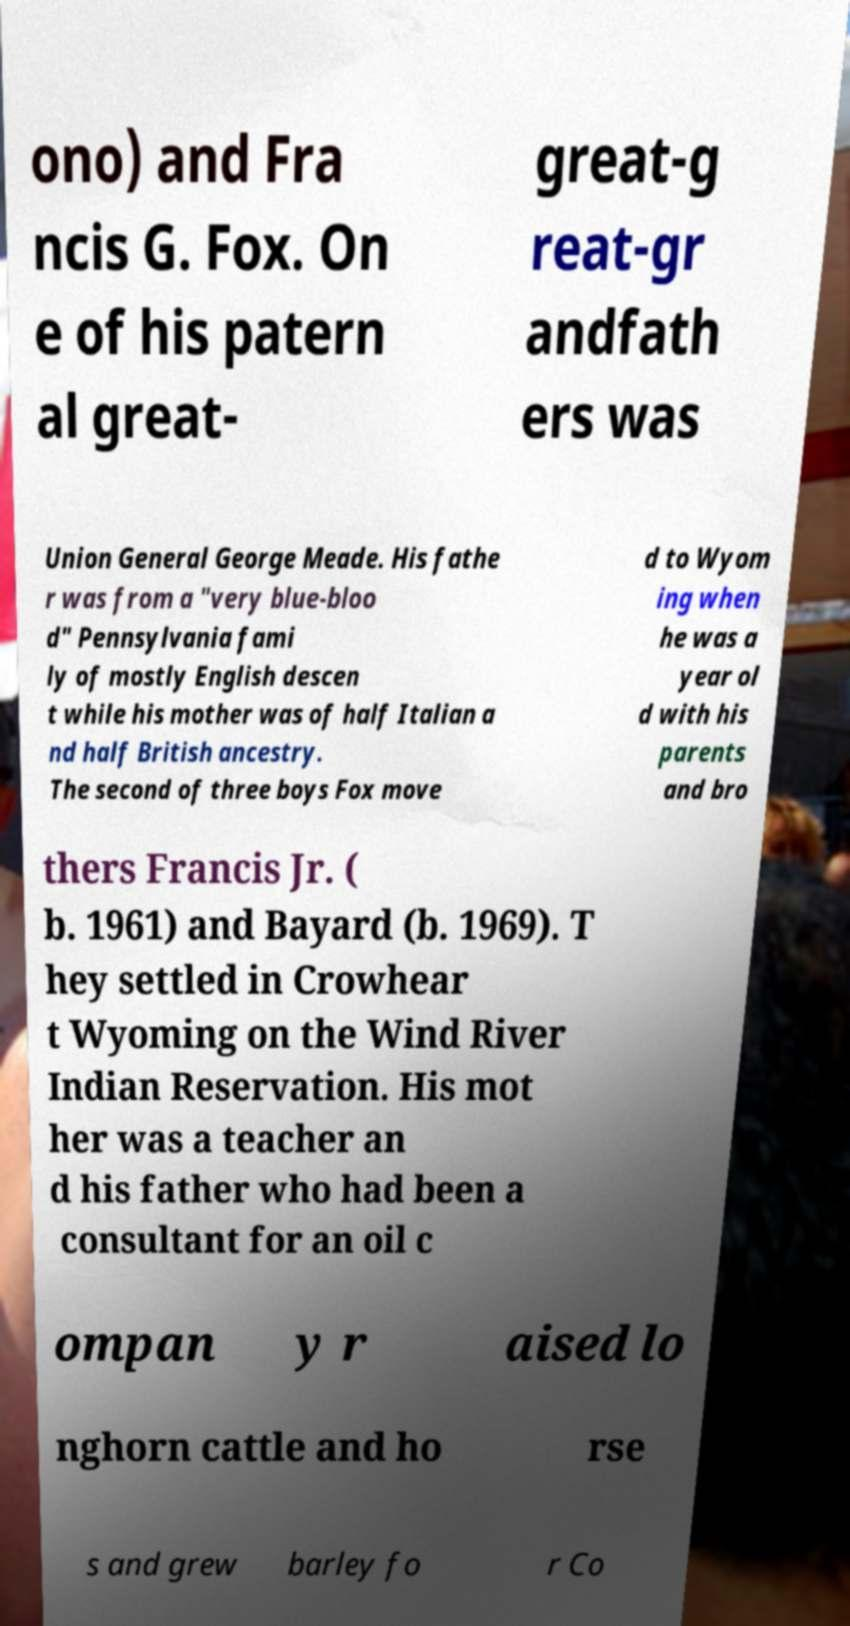Can you accurately transcribe the text from the provided image for me? ono) and Fra ncis G. Fox. On e of his patern al great- great-g reat-gr andfath ers was Union General George Meade. His fathe r was from a "very blue-bloo d" Pennsylvania fami ly of mostly English descen t while his mother was of half Italian a nd half British ancestry. The second of three boys Fox move d to Wyom ing when he was a year ol d with his parents and bro thers Francis Jr. ( b. 1961) and Bayard (b. 1969). T hey settled in Crowhear t Wyoming on the Wind River Indian Reservation. His mot her was a teacher an d his father who had been a consultant for an oil c ompan y r aised lo nghorn cattle and ho rse s and grew barley fo r Co 